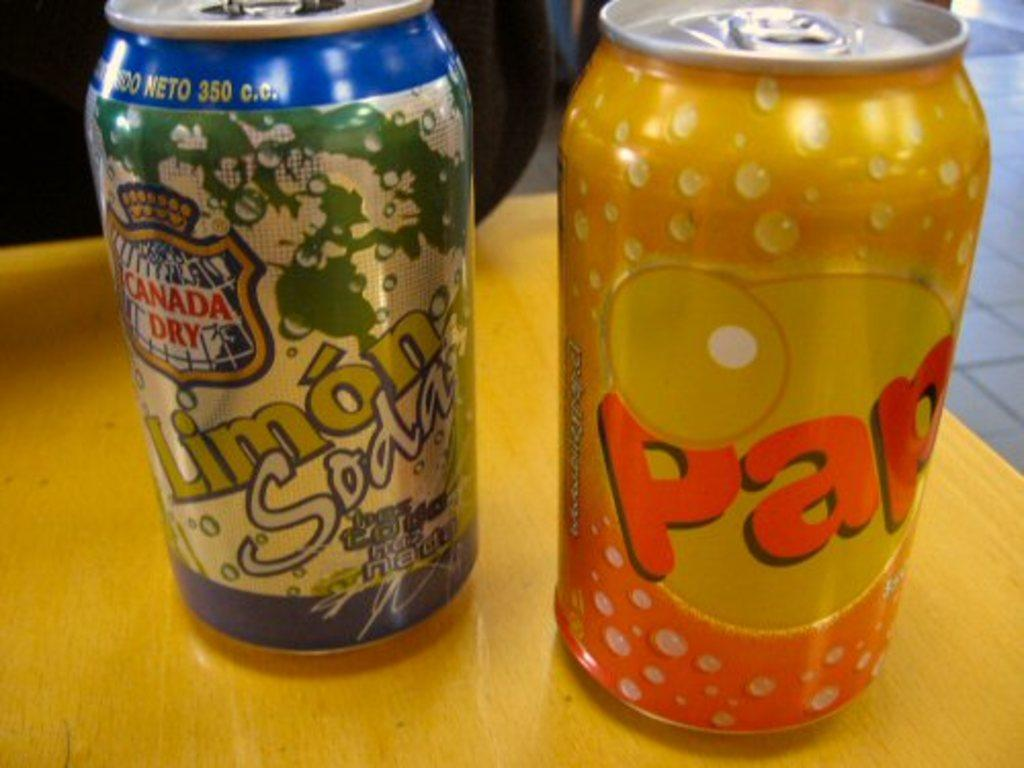<image>
Summarize the visual content of the image. Two soda cans sit side by side one of which is Limon Soda. 